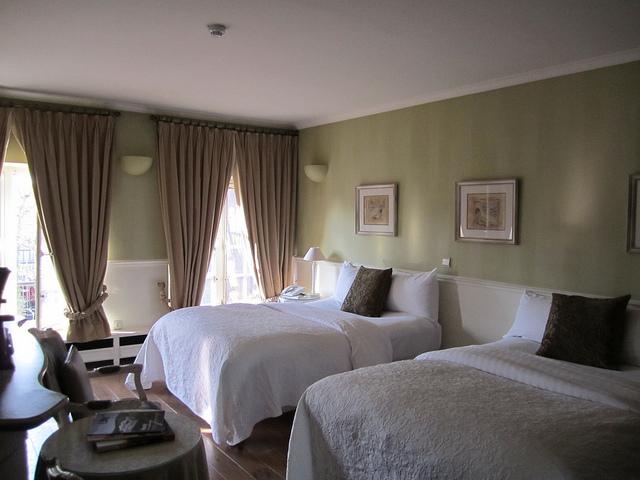How are the curtains held open?
Answer briefly. Ties. Which room is this?
Short answer required. Bedroom. How many people could sleep in this room?
Answer briefly. 4. Are the lights on?
Give a very brief answer. No. Is this room in a dormitory?
Be succinct. No. Can you see a window through the window?
Keep it brief. Yes. 